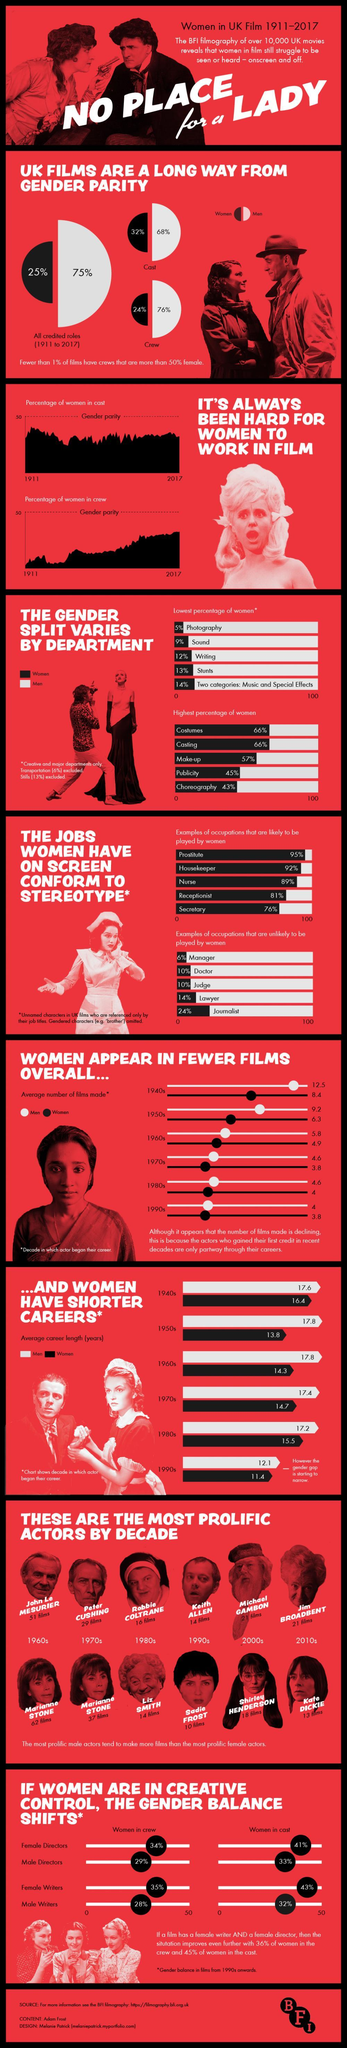What percentage of women performed all the credited roles in UK films during 1911-2017?
Answer the question with a short phrase. 25% Which department in UK films supported the least female population during 1911-2017? Photography What percentage of men performed all the credited roles in UK films during 1911-2017? 75% What percentage of UK film crew is female? 24% What is the average career length (in years) of women in UK films in the 1980s? 15.5 What percentage of men were into photography in UK films during 1911-2017? 95% What percentage of UK film casts is female? 32% What percentage of UK film writers were men during 1911-2017? 88% What percentage of women performed stunts in UK films during 1911-2017? 13% Which role is least performed by the women in UK films during 1911-2017? Manager 